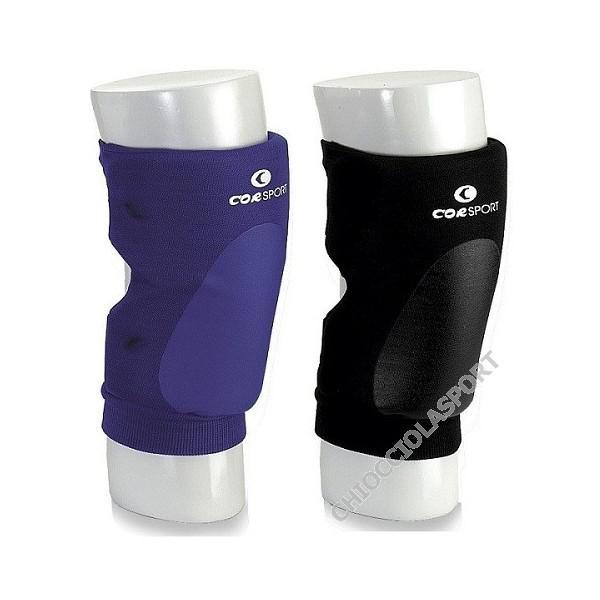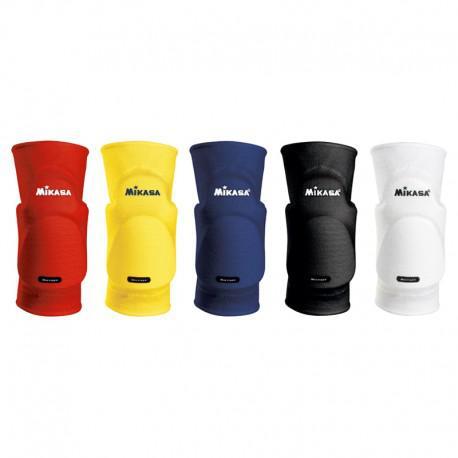The first image is the image on the left, the second image is the image on the right. Analyze the images presented: Is the assertion "There are exactly seven knee pads in total." valid? Answer yes or no. Yes. The first image is the image on the left, the second image is the image on the right. Evaluate the accuracy of this statement regarding the images: "There are exactly seven knee braces in total.". Is it true? Answer yes or no. Yes. 